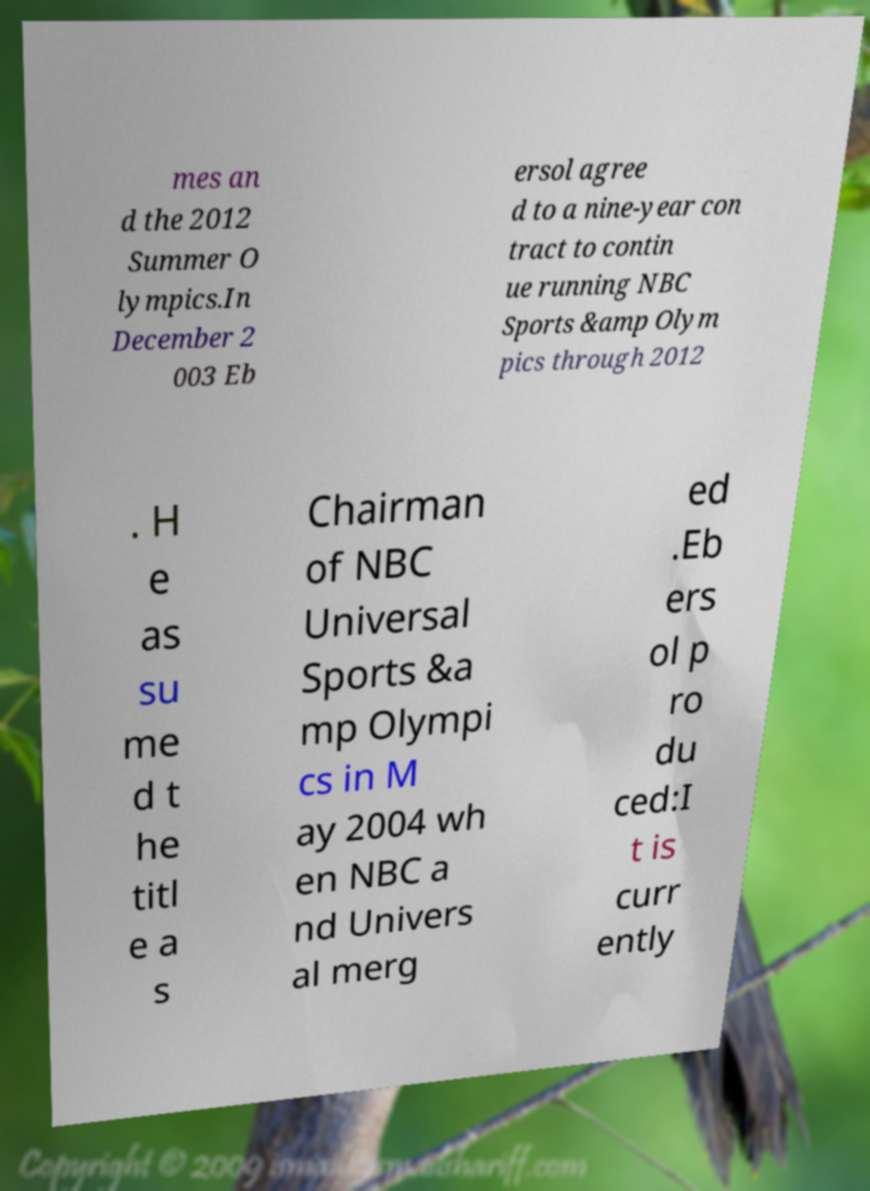Can you accurately transcribe the text from the provided image for me? mes an d the 2012 Summer O lympics.In December 2 003 Eb ersol agree d to a nine-year con tract to contin ue running NBC Sports &amp Olym pics through 2012 . H e as su me d t he titl e a s Chairman of NBC Universal Sports &a mp Olympi cs in M ay 2004 wh en NBC a nd Univers al merg ed .Eb ers ol p ro du ced:I t is curr ently 